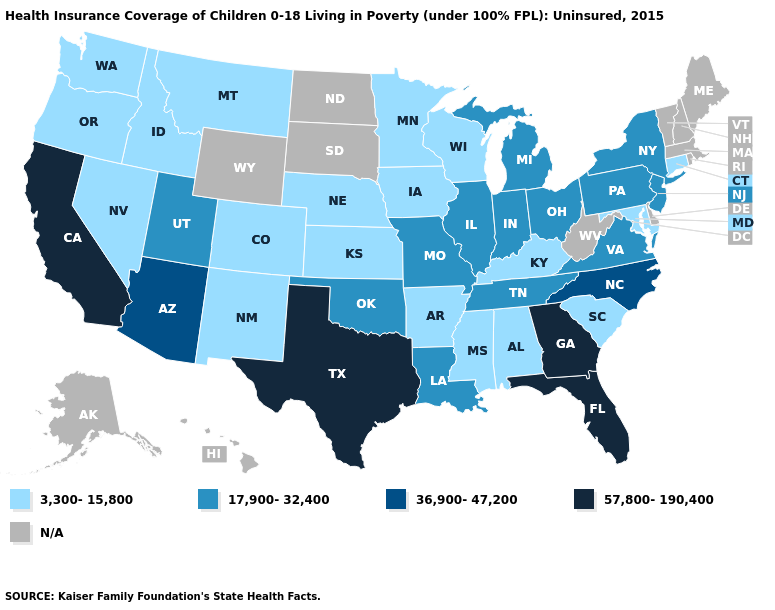What is the highest value in the South ?
Concise answer only. 57,800-190,400. What is the lowest value in the West?
Answer briefly. 3,300-15,800. Name the states that have a value in the range 17,900-32,400?
Quick response, please. Illinois, Indiana, Louisiana, Michigan, Missouri, New Jersey, New York, Ohio, Oklahoma, Pennsylvania, Tennessee, Utah, Virginia. Among the states that border South Carolina , does Georgia have the highest value?
Keep it brief. Yes. What is the value of Nevada?
Be succinct. 3,300-15,800. Among the states that border Alabama , does Mississippi have the lowest value?
Quick response, please. Yes. What is the value of Arkansas?
Quick response, please. 3,300-15,800. What is the highest value in the USA?
Concise answer only. 57,800-190,400. Does Minnesota have the lowest value in the USA?
Keep it brief. Yes. Name the states that have a value in the range 3,300-15,800?
Be succinct. Alabama, Arkansas, Colorado, Connecticut, Idaho, Iowa, Kansas, Kentucky, Maryland, Minnesota, Mississippi, Montana, Nebraska, Nevada, New Mexico, Oregon, South Carolina, Washington, Wisconsin. How many symbols are there in the legend?
Answer briefly. 5. Among the states that border Indiana , which have the highest value?
Give a very brief answer. Illinois, Michigan, Ohio. Name the states that have a value in the range 3,300-15,800?
Be succinct. Alabama, Arkansas, Colorado, Connecticut, Idaho, Iowa, Kansas, Kentucky, Maryland, Minnesota, Mississippi, Montana, Nebraska, Nevada, New Mexico, Oregon, South Carolina, Washington, Wisconsin. 